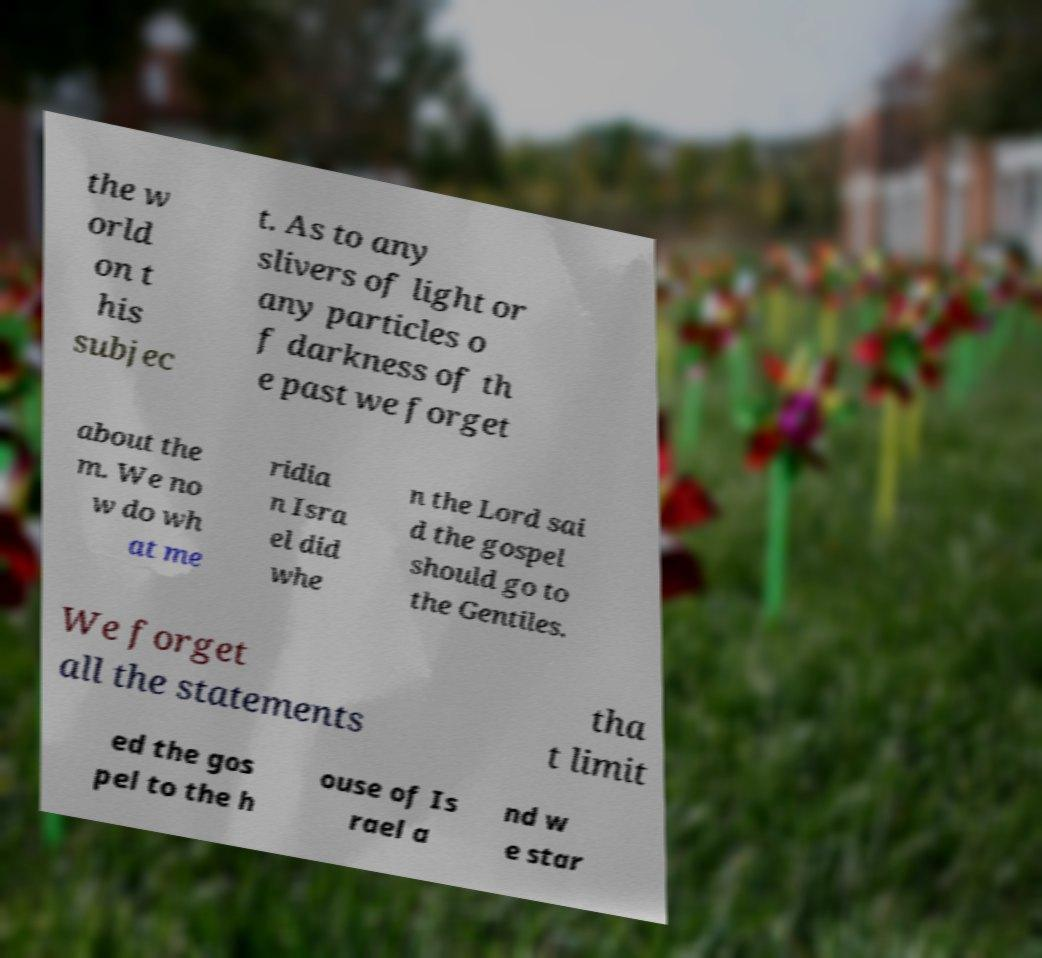Could you extract and type out the text from this image? the w orld on t his subjec t. As to any slivers of light or any particles o f darkness of th e past we forget about the m. We no w do wh at me ridia n Isra el did whe n the Lord sai d the gospel should go to the Gentiles. We forget all the statements tha t limit ed the gos pel to the h ouse of Is rael a nd w e star 